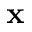Convert formula to latex. <formula><loc_0><loc_0><loc_500><loc_500>x</formula> 